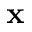Convert formula to latex. <formula><loc_0><loc_0><loc_500><loc_500>x</formula> 